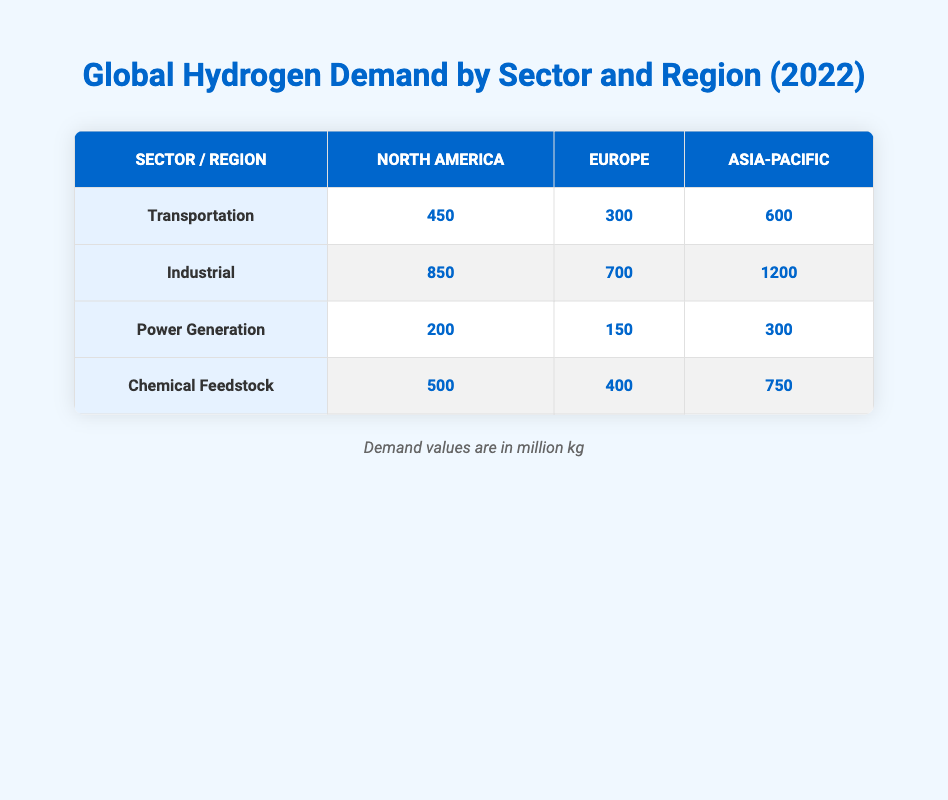What is the hydrogen demand for Transportation in Asia-Pacific? In the table, the row for the Transportation sector indicates that the demand in the Asia-Pacific region is 600 million kg.
Answer: 600 million kg Which sector has the highest demand in North America? By comparing the demand values of all sectors in North America, the Industrial sector has 850 million kg, which is higher than Transportation (450), Power Generation (200), and Chemical Feedstock (500).
Answer: Industrial What is the total demand for hydrogen in Europe across all sectors? To find the total demand in Europe, we add the values: Transportation (300) + Industrial (700) + Power Generation (150) + Chemical Feedstock (400) = 1550 million kg.
Answer: 1550 million kg Is the hydrogen demand for Chemical Feedstock higher in Asia-Pacific compared to Europe? For the Chemical Feedstock sector, the demand is 750 million kg in Asia-Pacific and 400 million kg in Europe. Therefore, yes, the demand is higher in Asia-Pacific.
Answer: Yes What is the difference in hydrogen demand for Industrial between North America and Europe? In North America, the Industrial demand is 850 million kg, while in Europe it is 700 million kg. The difference is 850 - 700 = 150 million kg.
Answer: 150 million kg Which region has the lowest hydrogen demand for Power Generation? The values indicate that North America has 200 million kg, Europe has 150 million kg, and Asia-Pacific has 300 million kg. The lowest demand is observed in Europe with 150 million kg.
Answer: Europe What is the average hydrogen demand for Transportation across all regions? To find the average, sum the values for Transportation: North America (450) + Europe (300) + Asia-Pacific (600) = 1350 million kg. There are three regions, so the average is 1350 / 3 = 450 million kg.
Answer: 450 million kg Which sector has the highest overall demand globally? By examining the demand values for all sectors, the Industrial sector has 850 (North America) + 700 (Europe) + 1200 (Asia-Pacific) = 2750 million kg, which is higher than the other sectors combined.
Answer: Industrial Is the hydrogen demand for Chemical Feedstock more than the demand for Power Generation in the Asia-Pacific region? The Chemical Feedstock demand in Asia-Pacific is 750 million kg, while Power Generation is 300 million kg. Since 750 is greater than 300, the answer is yes.
Answer: Yes 